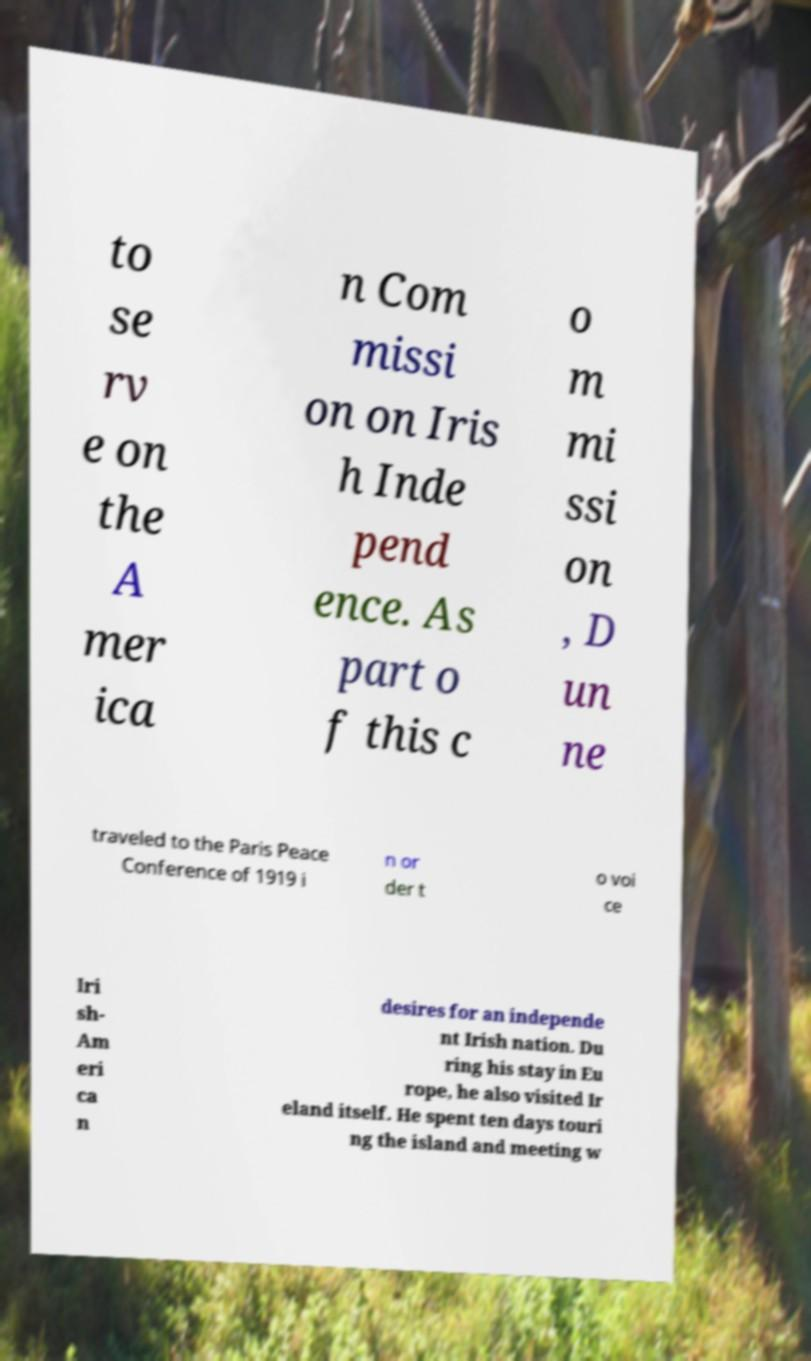I need the written content from this picture converted into text. Can you do that? to se rv e on the A mer ica n Com missi on on Iris h Inde pend ence. As part o f this c o m mi ssi on , D un ne traveled to the Paris Peace Conference of 1919 i n or der t o voi ce Iri sh- Am eri ca n desires for an independe nt Irish nation. Du ring his stay in Eu rope, he also visited Ir eland itself. He spent ten days touri ng the island and meeting w 